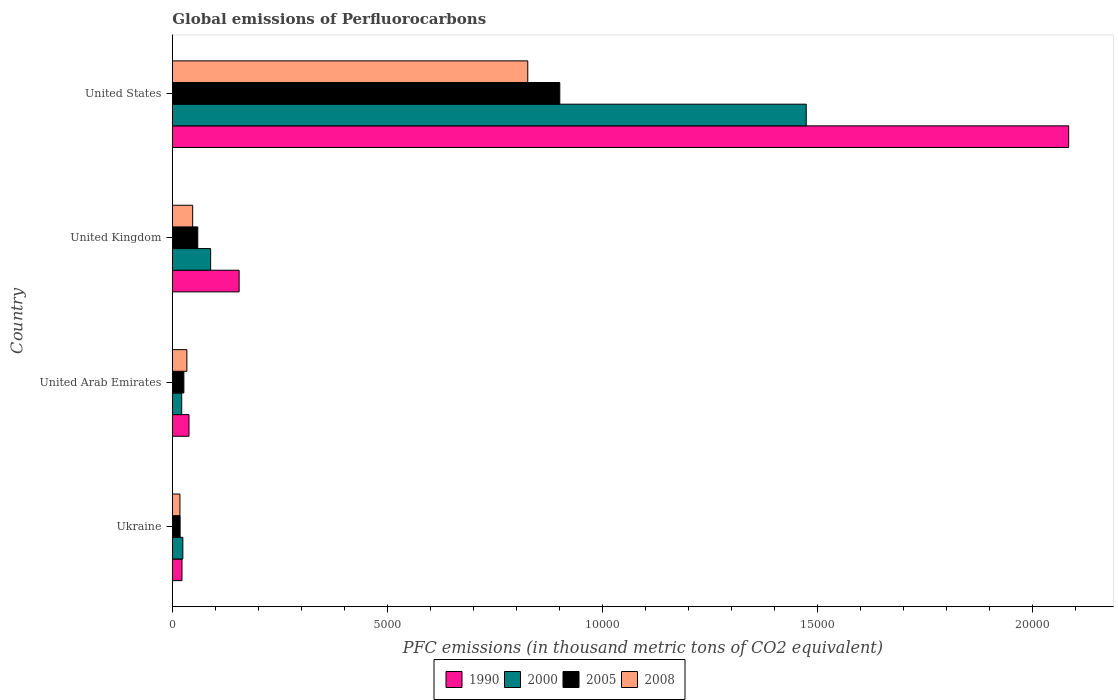Are the number of bars on each tick of the Y-axis equal?
Ensure brevity in your answer.  Yes. How many bars are there on the 2nd tick from the top?
Offer a very short reply. 4. What is the label of the 1st group of bars from the top?
Offer a terse response. United States. What is the global emissions of Perfluorocarbons in 1990 in Ukraine?
Ensure brevity in your answer.  224. Across all countries, what is the maximum global emissions of Perfluorocarbons in 1990?
Offer a terse response. 2.08e+04. Across all countries, what is the minimum global emissions of Perfluorocarbons in 2005?
Your answer should be compact. 180.5. In which country was the global emissions of Perfluorocarbons in 1990 minimum?
Keep it short and to the point. Ukraine. What is the total global emissions of Perfluorocarbons in 2008 in the graph?
Your answer should be very brief. 9250.5. What is the difference between the global emissions of Perfluorocarbons in 1990 in United Arab Emirates and that in United Kingdom?
Your answer should be very brief. -1165.2. What is the difference between the global emissions of Perfluorocarbons in 1990 in United States and the global emissions of Perfluorocarbons in 2005 in United Arab Emirates?
Give a very brief answer. 2.06e+04. What is the average global emissions of Perfluorocarbons in 2000 per country?
Provide a succinct answer. 4022.8. What is the difference between the global emissions of Perfluorocarbons in 2005 and global emissions of Perfluorocarbons in 2000 in United Kingdom?
Keep it short and to the point. -298.7. What is the ratio of the global emissions of Perfluorocarbons in 1990 in United Arab Emirates to that in United States?
Make the answer very short. 0.02. Is the difference between the global emissions of Perfluorocarbons in 2005 in Ukraine and United Arab Emirates greater than the difference between the global emissions of Perfluorocarbons in 2000 in Ukraine and United Arab Emirates?
Ensure brevity in your answer.  No. What is the difference between the highest and the second highest global emissions of Perfluorocarbons in 1990?
Offer a very short reply. 1.93e+04. What is the difference between the highest and the lowest global emissions of Perfluorocarbons in 1990?
Offer a terse response. 2.06e+04. In how many countries, is the global emissions of Perfluorocarbons in 2000 greater than the average global emissions of Perfluorocarbons in 2000 taken over all countries?
Your answer should be compact. 1. Is it the case that in every country, the sum of the global emissions of Perfluorocarbons in 2000 and global emissions of Perfluorocarbons in 1990 is greater than the sum of global emissions of Perfluorocarbons in 2005 and global emissions of Perfluorocarbons in 2008?
Your answer should be very brief. Yes. What does the 4th bar from the top in United Kingdom represents?
Your answer should be very brief. 1990. Is it the case that in every country, the sum of the global emissions of Perfluorocarbons in 2008 and global emissions of Perfluorocarbons in 2005 is greater than the global emissions of Perfluorocarbons in 2000?
Provide a short and direct response. Yes. Are all the bars in the graph horizontal?
Provide a short and direct response. Yes. Does the graph contain grids?
Provide a succinct answer. No. Where does the legend appear in the graph?
Ensure brevity in your answer.  Bottom center. How many legend labels are there?
Offer a very short reply. 4. What is the title of the graph?
Your answer should be compact. Global emissions of Perfluorocarbons. What is the label or title of the X-axis?
Give a very brief answer. PFC emissions (in thousand metric tons of CO2 equivalent). What is the PFC emissions (in thousand metric tons of CO2 equivalent) of 1990 in Ukraine?
Your response must be concise. 224. What is the PFC emissions (in thousand metric tons of CO2 equivalent) of 2000 in Ukraine?
Your answer should be compact. 244.1. What is the PFC emissions (in thousand metric tons of CO2 equivalent) in 2005 in Ukraine?
Keep it short and to the point. 180.5. What is the PFC emissions (in thousand metric tons of CO2 equivalent) in 2008 in Ukraine?
Keep it short and to the point. 176.5. What is the PFC emissions (in thousand metric tons of CO2 equivalent) of 1990 in United Arab Emirates?
Provide a succinct answer. 387.3. What is the PFC emissions (in thousand metric tons of CO2 equivalent) of 2000 in United Arab Emirates?
Provide a short and direct response. 218. What is the PFC emissions (in thousand metric tons of CO2 equivalent) of 2005 in United Arab Emirates?
Your response must be concise. 267.9. What is the PFC emissions (in thousand metric tons of CO2 equivalent) of 2008 in United Arab Emirates?
Provide a short and direct response. 337.6. What is the PFC emissions (in thousand metric tons of CO2 equivalent) in 1990 in United Kingdom?
Your answer should be compact. 1552.5. What is the PFC emissions (in thousand metric tons of CO2 equivalent) in 2000 in United Kingdom?
Offer a terse response. 890.1. What is the PFC emissions (in thousand metric tons of CO2 equivalent) of 2005 in United Kingdom?
Your response must be concise. 591.4. What is the PFC emissions (in thousand metric tons of CO2 equivalent) in 2008 in United Kingdom?
Provide a succinct answer. 472.4. What is the PFC emissions (in thousand metric tons of CO2 equivalent) in 1990 in United States?
Provide a succinct answer. 2.08e+04. What is the PFC emissions (in thousand metric tons of CO2 equivalent) in 2000 in United States?
Ensure brevity in your answer.  1.47e+04. What is the PFC emissions (in thousand metric tons of CO2 equivalent) of 2005 in United States?
Keep it short and to the point. 9008.7. What is the PFC emissions (in thousand metric tons of CO2 equivalent) in 2008 in United States?
Offer a very short reply. 8264. Across all countries, what is the maximum PFC emissions (in thousand metric tons of CO2 equivalent) in 1990?
Keep it short and to the point. 2.08e+04. Across all countries, what is the maximum PFC emissions (in thousand metric tons of CO2 equivalent) of 2000?
Your answer should be compact. 1.47e+04. Across all countries, what is the maximum PFC emissions (in thousand metric tons of CO2 equivalent) of 2005?
Provide a succinct answer. 9008.7. Across all countries, what is the maximum PFC emissions (in thousand metric tons of CO2 equivalent) in 2008?
Provide a short and direct response. 8264. Across all countries, what is the minimum PFC emissions (in thousand metric tons of CO2 equivalent) of 1990?
Make the answer very short. 224. Across all countries, what is the minimum PFC emissions (in thousand metric tons of CO2 equivalent) in 2000?
Ensure brevity in your answer.  218. Across all countries, what is the minimum PFC emissions (in thousand metric tons of CO2 equivalent) of 2005?
Provide a short and direct response. 180.5. Across all countries, what is the minimum PFC emissions (in thousand metric tons of CO2 equivalent) of 2008?
Your answer should be compact. 176.5. What is the total PFC emissions (in thousand metric tons of CO2 equivalent) in 1990 in the graph?
Offer a very short reply. 2.30e+04. What is the total PFC emissions (in thousand metric tons of CO2 equivalent) of 2000 in the graph?
Your response must be concise. 1.61e+04. What is the total PFC emissions (in thousand metric tons of CO2 equivalent) of 2005 in the graph?
Your answer should be compact. 1.00e+04. What is the total PFC emissions (in thousand metric tons of CO2 equivalent) in 2008 in the graph?
Your answer should be very brief. 9250.5. What is the difference between the PFC emissions (in thousand metric tons of CO2 equivalent) of 1990 in Ukraine and that in United Arab Emirates?
Make the answer very short. -163.3. What is the difference between the PFC emissions (in thousand metric tons of CO2 equivalent) in 2000 in Ukraine and that in United Arab Emirates?
Keep it short and to the point. 26.1. What is the difference between the PFC emissions (in thousand metric tons of CO2 equivalent) of 2005 in Ukraine and that in United Arab Emirates?
Ensure brevity in your answer.  -87.4. What is the difference between the PFC emissions (in thousand metric tons of CO2 equivalent) of 2008 in Ukraine and that in United Arab Emirates?
Offer a terse response. -161.1. What is the difference between the PFC emissions (in thousand metric tons of CO2 equivalent) of 1990 in Ukraine and that in United Kingdom?
Your answer should be compact. -1328.5. What is the difference between the PFC emissions (in thousand metric tons of CO2 equivalent) in 2000 in Ukraine and that in United Kingdom?
Keep it short and to the point. -646. What is the difference between the PFC emissions (in thousand metric tons of CO2 equivalent) of 2005 in Ukraine and that in United Kingdom?
Offer a very short reply. -410.9. What is the difference between the PFC emissions (in thousand metric tons of CO2 equivalent) of 2008 in Ukraine and that in United Kingdom?
Ensure brevity in your answer.  -295.9. What is the difference between the PFC emissions (in thousand metric tons of CO2 equivalent) of 1990 in Ukraine and that in United States?
Your answer should be compact. -2.06e+04. What is the difference between the PFC emissions (in thousand metric tons of CO2 equivalent) of 2000 in Ukraine and that in United States?
Your response must be concise. -1.45e+04. What is the difference between the PFC emissions (in thousand metric tons of CO2 equivalent) in 2005 in Ukraine and that in United States?
Offer a very short reply. -8828.2. What is the difference between the PFC emissions (in thousand metric tons of CO2 equivalent) of 2008 in Ukraine and that in United States?
Ensure brevity in your answer.  -8087.5. What is the difference between the PFC emissions (in thousand metric tons of CO2 equivalent) of 1990 in United Arab Emirates and that in United Kingdom?
Offer a very short reply. -1165.2. What is the difference between the PFC emissions (in thousand metric tons of CO2 equivalent) in 2000 in United Arab Emirates and that in United Kingdom?
Make the answer very short. -672.1. What is the difference between the PFC emissions (in thousand metric tons of CO2 equivalent) of 2005 in United Arab Emirates and that in United Kingdom?
Your answer should be very brief. -323.5. What is the difference between the PFC emissions (in thousand metric tons of CO2 equivalent) of 2008 in United Arab Emirates and that in United Kingdom?
Ensure brevity in your answer.  -134.8. What is the difference between the PFC emissions (in thousand metric tons of CO2 equivalent) in 1990 in United Arab Emirates and that in United States?
Make the answer very short. -2.05e+04. What is the difference between the PFC emissions (in thousand metric tons of CO2 equivalent) of 2000 in United Arab Emirates and that in United States?
Your answer should be very brief. -1.45e+04. What is the difference between the PFC emissions (in thousand metric tons of CO2 equivalent) of 2005 in United Arab Emirates and that in United States?
Your answer should be compact. -8740.8. What is the difference between the PFC emissions (in thousand metric tons of CO2 equivalent) of 2008 in United Arab Emirates and that in United States?
Provide a succinct answer. -7926.4. What is the difference between the PFC emissions (in thousand metric tons of CO2 equivalent) of 1990 in United Kingdom and that in United States?
Offer a very short reply. -1.93e+04. What is the difference between the PFC emissions (in thousand metric tons of CO2 equivalent) of 2000 in United Kingdom and that in United States?
Offer a very short reply. -1.38e+04. What is the difference between the PFC emissions (in thousand metric tons of CO2 equivalent) of 2005 in United Kingdom and that in United States?
Your response must be concise. -8417.3. What is the difference between the PFC emissions (in thousand metric tons of CO2 equivalent) of 2008 in United Kingdom and that in United States?
Give a very brief answer. -7791.6. What is the difference between the PFC emissions (in thousand metric tons of CO2 equivalent) in 1990 in Ukraine and the PFC emissions (in thousand metric tons of CO2 equivalent) in 2005 in United Arab Emirates?
Your answer should be compact. -43.9. What is the difference between the PFC emissions (in thousand metric tons of CO2 equivalent) in 1990 in Ukraine and the PFC emissions (in thousand metric tons of CO2 equivalent) in 2008 in United Arab Emirates?
Offer a very short reply. -113.6. What is the difference between the PFC emissions (in thousand metric tons of CO2 equivalent) of 2000 in Ukraine and the PFC emissions (in thousand metric tons of CO2 equivalent) of 2005 in United Arab Emirates?
Provide a succinct answer. -23.8. What is the difference between the PFC emissions (in thousand metric tons of CO2 equivalent) in 2000 in Ukraine and the PFC emissions (in thousand metric tons of CO2 equivalent) in 2008 in United Arab Emirates?
Offer a very short reply. -93.5. What is the difference between the PFC emissions (in thousand metric tons of CO2 equivalent) of 2005 in Ukraine and the PFC emissions (in thousand metric tons of CO2 equivalent) of 2008 in United Arab Emirates?
Provide a succinct answer. -157.1. What is the difference between the PFC emissions (in thousand metric tons of CO2 equivalent) of 1990 in Ukraine and the PFC emissions (in thousand metric tons of CO2 equivalent) of 2000 in United Kingdom?
Your answer should be compact. -666.1. What is the difference between the PFC emissions (in thousand metric tons of CO2 equivalent) of 1990 in Ukraine and the PFC emissions (in thousand metric tons of CO2 equivalent) of 2005 in United Kingdom?
Give a very brief answer. -367.4. What is the difference between the PFC emissions (in thousand metric tons of CO2 equivalent) in 1990 in Ukraine and the PFC emissions (in thousand metric tons of CO2 equivalent) in 2008 in United Kingdom?
Provide a succinct answer. -248.4. What is the difference between the PFC emissions (in thousand metric tons of CO2 equivalent) in 2000 in Ukraine and the PFC emissions (in thousand metric tons of CO2 equivalent) in 2005 in United Kingdom?
Keep it short and to the point. -347.3. What is the difference between the PFC emissions (in thousand metric tons of CO2 equivalent) of 2000 in Ukraine and the PFC emissions (in thousand metric tons of CO2 equivalent) of 2008 in United Kingdom?
Offer a very short reply. -228.3. What is the difference between the PFC emissions (in thousand metric tons of CO2 equivalent) in 2005 in Ukraine and the PFC emissions (in thousand metric tons of CO2 equivalent) in 2008 in United Kingdom?
Ensure brevity in your answer.  -291.9. What is the difference between the PFC emissions (in thousand metric tons of CO2 equivalent) of 1990 in Ukraine and the PFC emissions (in thousand metric tons of CO2 equivalent) of 2000 in United States?
Offer a terse response. -1.45e+04. What is the difference between the PFC emissions (in thousand metric tons of CO2 equivalent) of 1990 in Ukraine and the PFC emissions (in thousand metric tons of CO2 equivalent) of 2005 in United States?
Ensure brevity in your answer.  -8784.7. What is the difference between the PFC emissions (in thousand metric tons of CO2 equivalent) in 1990 in Ukraine and the PFC emissions (in thousand metric tons of CO2 equivalent) in 2008 in United States?
Offer a terse response. -8040. What is the difference between the PFC emissions (in thousand metric tons of CO2 equivalent) in 2000 in Ukraine and the PFC emissions (in thousand metric tons of CO2 equivalent) in 2005 in United States?
Your answer should be compact. -8764.6. What is the difference between the PFC emissions (in thousand metric tons of CO2 equivalent) of 2000 in Ukraine and the PFC emissions (in thousand metric tons of CO2 equivalent) of 2008 in United States?
Make the answer very short. -8019.9. What is the difference between the PFC emissions (in thousand metric tons of CO2 equivalent) in 2005 in Ukraine and the PFC emissions (in thousand metric tons of CO2 equivalent) in 2008 in United States?
Offer a terse response. -8083.5. What is the difference between the PFC emissions (in thousand metric tons of CO2 equivalent) in 1990 in United Arab Emirates and the PFC emissions (in thousand metric tons of CO2 equivalent) in 2000 in United Kingdom?
Ensure brevity in your answer.  -502.8. What is the difference between the PFC emissions (in thousand metric tons of CO2 equivalent) in 1990 in United Arab Emirates and the PFC emissions (in thousand metric tons of CO2 equivalent) in 2005 in United Kingdom?
Your answer should be very brief. -204.1. What is the difference between the PFC emissions (in thousand metric tons of CO2 equivalent) of 1990 in United Arab Emirates and the PFC emissions (in thousand metric tons of CO2 equivalent) of 2008 in United Kingdom?
Make the answer very short. -85.1. What is the difference between the PFC emissions (in thousand metric tons of CO2 equivalent) in 2000 in United Arab Emirates and the PFC emissions (in thousand metric tons of CO2 equivalent) in 2005 in United Kingdom?
Give a very brief answer. -373.4. What is the difference between the PFC emissions (in thousand metric tons of CO2 equivalent) of 2000 in United Arab Emirates and the PFC emissions (in thousand metric tons of CO2 equivalent) of 2008 in United Kingdom?
Ensure brevity in your answer.  -254.4. What is the difference between the PFC emissions (in thousand metric tons of CO2 equivalent) of 2005 in United Arab Emirates and the PFC emissions (in thousand metric tons of CO2 equivalent) of 2008 in United Kingdom?
Provide a short and direct response. -204.5. What is the difference between the PFC emissions (in thousand metric tons of CO2 equivalent) of 1990 in United Arab Emirates and the PFC emissions (in thousand metric tons of CO2 equivalent) of 2000 in United States?
Provide a succinct answer. -1.44e+04. What is the difference between the PFC emissions (in thousand metric tons of CO2 equivalent) of 1990 in United Arab Emirates and the PFC emissions (in thousand metric tons of CO2 equivalent) of 2005 in United States?
Keep it short and to the point. -8621.4. What is the difference between the PFC emissions (in thousand metric tons of CO2 equivalent) in 1990 in United Arab Emirates and the PFC emissions (in thousand metric tons of CO2 equivalent) in 2008 in United States?
Offer a terse response. -7876.7. What is the difference between the PFC emissions (in thousand metric tons of CO2 equivalent) of 2000 in United Arab Emirates and the PFC emissions (in thousand metric tons of CO2 equivalent) of 2005 in United States?
Offer a very short reply. -8790.7. What is the difference between the PFC emissions (in thousand metric tons of CO2 equivalent) in 2000 in United Arab Emirates and the PFC emissions (in thousand metric tons of CO2 equivalent) in 2008 in United States?
Ensure brevity in your answer.  -8046. What is the difference between the PFC emissions (in thousand metric tons of CO2 equivalent) of 2005 in United Arab Emirates and the PFC emissions (in thousand metric tons of CO2 equivalent) of 2008 in United States?
Give a very brief answer. -7996.1. What is the difference between the PFC emissions (in thousand metric tons of CO2 equivalent) of 1990 in United Kingdom and the PFC emissions (in thousand metric tons of CO2 equivalent) of 2000 in United States?
Offer a very short reply. -1.32e+04. What is the difference between the PFC emissions (in thousand metric tons of CO2 equivalent) in 1990 in United Kingdom and the PFC emissions (in thousand metric tons of CO2 equivalent) in 2005 in United States?
Your response must be concise. -7456.2. What is the difference between the PFC emissions (in thousand metric tons of CO2 equivalent) of 1990 in United Kingdom and the PFC emissions (in thousand metric tons of CO2 equivalent) of 2008 in United States?
Give a very brief answer. -6711.5. What is the difference between the PFC emissions (in thousand metric tons of CO2 equivalent) in 2000 in United Kingdom and the PFC emissions (in thousand metric tons of CO2 equivalent) in 2005 in United States?
Provide a short and direct response. -8118.6. What is the difference between the PFC emissions (in thousand metric tons of CO2 equivalent) of 2000 in United Kingdom and the PFC emissions (in thousand metric tons of CO2 equivalent) of 2008 in United States?
Give a very brief answer. -7373.9. What is the difference between the PFC emissions (in thousand metric tons of CO2 equivalent) of 2005 in United Kingdom and the PFC emissions (in thousand metric tons of CO2 equivalent) of 2008 in United States?
Give a very brief answer. -7672.6. What is the average PFC emissions (in thousand metric tons of CO2 equivalent) in 1990 per country?
Give a very brief answer. 5751.27. What is the average PFC emissions (in thousand metric tons of CO2 equivalent) in 2000 per country?
Make the answer very short. 4022.8. What is the average PFC emissions (in thousand metric tons of CO2 equivalent) of 2005 per country?
Offer a very short reply. 2512.12. What is the average PFC emissions (in thousand metric tons of CO2 equivalent) of 2008 per country?
Your answer should be very brief. 2312.62. What is the difference between the PFC emissions (in thousand metric tons of CO2 equivalent) of 1990 and PFC emissions (in thousand metric tons of CO2 equivalent) of 2000 in Ukraine?
Your response must be concise. -20.1. What is the difference between the PFC emissions (in thousand metric tons of CO2 equivalent) of 1990 and PFC emissions (in thousand metric tons of CO2 equivalent) of 2005 in Ukraine?
Your answer should be very brief. 43.5. What is the difference between the PFC emissions (in thousand metric tons of CO2 equivalent) in 1990 and PFC emissions (in thousand metric tons of CO2 equivalent) in 2008 in Ukraine?
Offer a very short reply. 47.5. What is the difference between the PFC emissions (in thousand metric tons of CO2 equivalent) of 2000 and PFC emissions (in thousand metric tons of CO2 equivalent) of 2005 in Ukraine?
Give a very brief answer. 63.6. What is the difference between the PFC emissions (in thousand metric tons of CO2 equivalent) of 2000 and PFC emissions (in thousand metric tons of CO2 equivalent) of 2008 in Ukraine?
Keep it short and to the point. 67.6. What is the difference between the PFC emissions (in thousand metric tons of CO2 equivalent) of 2005 and PFC emissions (in thousand metric tons of CO2 equivalent) of 2008 in Ukraine?
Your answer should be compact. 4. What is the difference between the PFC emissions (in thousand metric tons of CO2 equivalent) in 1990 and PFC emissions (in thousand metric tons of CO2 equivalent) in 2000 in United Arab Emirates?
Give a very brief answer. 169.3. What is the difference between the PFC emissions (in thousand metric tons of CO2 equivalent) of 1990 and PFC emissions (in thousand metric tons of CO2 equivalent) of 2005 in United Arab Emirates?
Make the answer very short. 119.4. What is the difference between the PFC emissions (in thousand metric tons of CO2 equivalent) of 1990 and PFC emissions (in thousand metric tons of CO2 equivalent) of 2008 in United Arab Emirates?
Keep it short and to the point. 49.7. What is the difference between the PFC emissions (in thousand metric tons of CO2 equivalent) in 2000 and PFC emissions (in thousand metric tons of CO2 equivalent) in 2005 in United Arab Emirates?
Your response must be concise. -49.9. What is the difference between the PFC emissions (in thousand metric tons of CO2 equivalent) of 2000 and PFC emissions (in thousand metric tons of CO2 equivalent) of 2008 in United Arab Emirates?
Make the answer very short. -119.6. What is the difference between the PFC emissions (in thousand metric tons of CO2 equivalent) in 2005 and PFC emissions (in thousand metric tons of CO2 equivalent) in 2008 in United Arab Emirates?
Give a very brief answer. -69.7. What is the difference between the PFC emissions (in thousand metric tons of CO2 equivalent) in 1990 and PFC emissions (in thousand metric tons of CO2 equivalent) in 2000 in United Kingdom?
Ensure brevity in your answer.  662.4. What is the difference between the PFC emissions (in thousand metric tons of CO2 equivalent) in 1990 and PFC emissions (in thousand metric tons of CO2 equivalent) in 2005 in United Kingdom?
Your answer should be very brief. 961.1. What is the difference between the PFC emissions (in thousand metric tons of CO2 equivalent) of 1990 and PFC emissions (in thousand metric tons of CO2 equivalent) of 2008 in United Kingdom?
Your answer should be compact. 1080.1. What is the difference between the PFC emissions (in thousand metric tons of CO2 equivalent) of 2000 and PFC emissions (in thousand metric tons of CO2 equivalent) of 2005 in United Kingdom?
Keep it short and to the point. 298.7. What is the difference between the PFC emissions (in thousand metric tons of CO2 equivalent) of 2000 and PFC emissions (in thousand metric tons of CO2 equivalent) of 2008 in United Kingdom?
Provide a short and direct response. 417.7. What is the difference between the PFC emissions (in thousand metric tons of CO2 equivalent) of 2005 and PFC emissions (in thousand metric tons of CO2 equivalent) of 2008 in United Kingdom?
Your response must be concise. 119. What is the difference between the PFC emissions (in thousand metric tons of CO2 equivalent) in 1990 and PFC emissions (in thousand metric tons of CO2 equivalent) in 2000 in United States?
Make the answer very short. 6102.3. What is the difference between the PFC emissions (in thousand metric tons of CO2 equivalent) in 1990 and PFC emissions (in thousand metric tons of CO2 equivalent) in 2005 in United States?
Provide a succinct answer. 1.18e+04. What is the difference between the PFC emissions (in thousand metric tons of CO2 equivalent) in 1990 and PFC emissions (in thousand metric tons of CO2 equivalent) in 2008 in United States?
Offer a very short reply. 1.26e+04. What is the difference between the PFC emissions (in thousand metric tons of CO2 equivalent) of 2000 and PFC emissions (in thousand metric tons of CO2 equivalent) of 2005 in United States?
Give a very brief answer. 5730.3. What is the difference between the PFC emissions (in thousand metric tons of CO2 equivalent) of 2000 and PFC emissions (in thousand metric tons of CO2 equivalent) of 2008 in United States?
Your answer should be compact. 6475. What is the difference between the PFC emissions (in thousand metric tons of CO2 equivalent) of 2005 and PFC emissions (in thousand metric tons of CO2 equivalent) of 2008 in United States?
Your response must be concise. 744.7. What is the ratio of the PFC emissions (in thousand metric tons of CO2 equivalent) in 1990 in Ukraine to that in United Arab Emirates?
Provide a short and direct response. 0.58. What is the ratio of the PFC emissions (in thousand metric tons of CO2 equivalent) in 2000 in Ukraine to that in United Arab Emirates?
Make the answer very short. 1.12. What is the ratio of the PFC emissions (in thousand metric tons of CO2 equivalent) in 2005 in Ukraine to that in United Arab Emirates?
Your answer should be compact. 0.67. What is the ratio of the PFC emissions (in thousand metric tons of CO2 equivalent) of 2008 in Ukraine to that in United Arab Emirates?
Ensure brevity in your answer.  0.52. What is the ratio of the PFC emissions (in thousand metric tons of CO2 equivalent) of 1990 in Ukraine to that in United Kingdom?
Provide a succinct answer. 0.14. What is the ratio of the PFC emissions (in thousand metric tons of CO2 equivalent) in 2000 in Ukraine to that in United Kingdom?
Give a very brief answer. 0.27. What is the ratio of the PFC emissions (in thousand metric tons of CO2 equivalent) of 2005 in Ukraine to that in United Kingdom?
Offer a terse response. 0.31. What is the ratio of the PFC emissions (in thousand metric tons of CO2 equivalent) in 2008 in Ukraine to that in United Kingdom?
Your answer should be very brief. 0.37. What is the ratio of the PFC emissions (in thousand metric tons of CO2 equivalent) of 1990 in Ukraine to that in United States?
Your answer should be very brief. 0.01. What is the ratio of the PFC emissions (in thousand metric tons of CO2 equivalent) in 2000 in Ukraine to that in United States?
Your answer should be very brief. 0.02. What is the ratio of the PFC emissions (in thousand metric tons of CO2 equivalent) in 2005 in Ukraine to that in United States?
Your answer should be very brief. 0.02. What is the ratio of the PFC emissions (in thousand metric tons of CO2 equivalent) of 2008 in Ukraine to that in United States?
Ensure brevity in your answer.  0.02. What is the ratio of the PFC emissions (in thousand metric tons of CO2 equivalent) of 1990 in United Arab Emirates to that in United Kingdom?
Keep it short and to the point. 0.25. What is the ratio of the PFC emissions (in thousand metric tons of CO2 equivalent) in 2000 in United Arab Emirates to that in United Kingdom?
Give a very brief answer. 0.24. What is the ratio of the PFC emissions (in thousand metric tons of CO2 equivalent) in 2005 in United Arab Emirates to that in United Kingdom?
Offer a terse response. 0.45. What is the ratio of the PFC emissions (in thousand metric tons of CO2 equivalent) in 2008 in United Arab Emirates to that in United Kingdom?
Offer a very short reply. 0.71. What is the ratio of the PFC emissions (in thousand metric tons of CO2 equivalent) in 1990 in United Arab Emirates to that in United States?
Your response must be concise. 0.02. What is the ratio of the PFC emissions (in thousand metric tons of CO2 equivalent) in 2000 in United Arab Emirates to that in United States?
Offer a terse response. 0.01. What is the ratio of the PFC emissions (in thousand metric tons of CO2 equivalent) in 2005 in United Arab Emirates to that in United States?
Your response must be concise. 0.03. What is the ratio of the PFC emissions (in thousand metric tons of CO2 equivalent) of 2008 in United Arab Emirates to that in United States?
Provide a short and direct response. 0.04. What is the ratio of the PFC emissions (in thousand metric tons of CO2 equivalent) of 1990 in United Kingdom to that in United States?
Offer a terse response. 0.07. What is the ratio of the PFC emissions (in thousand metric tons of CO2 equivalent) of 2000 in United Kingdom to that in United States?
Give a very brief answer. 0.06. What is the ratio of the PFC emissions (in thousand metric tons of CO2 equivalent) of 2005 in United Kingdom to that in United States?
Make the answer very short. 0.07. What is the ratio of the PFC emissions (in thousand metric tons of CO2 equivalent) of 2008 in United Kingdom to that in United States?
Keep it short and to the point. 0.06. What is the difference between the highest and the second highest PFC emissions (in thousand metric tons of CO2 equivalent) in 1990?
Ensure brevity in your answer.  1.93e+04. What is the difference between the highest and the second highest PFC emissions (in thousand metric tons of CO2 equivalent) of 2000?
Offer a very short reply. 1.38e+04. What is the difference between the highest and the second highest PFC emissions (in thousand metric tons of CO2 equivalent) of 2005?
Give a very brief answer. 8417.3. What is the difference between the highest and the second highest PFC emissions (in thousand metric tons of CO2 equivalent) of 2008?
Offer a terse response. 7791.6. What is the difference between the highest and the lowest PFC emissions (in thousand metric tons of CO2 equivalent) of 1990?
Your response must be concise. 2.06e+04. What is the difference between the highest and the lowest PFC emissions (in thousand metric tons of CO2 equivalent) of 2000?
Your answer should be very brief. 1.45e+04. What is the difference between the highest and the lowest PFC emissions (in thousand metric tons of CO2 equivalent) in 2005?
Offer a terse response. 8828.2. What is the difference between the highest and the lowest PFC emissions (in thousand metric tons of CO2 equivalent) of 2008?
Provide a short and direct response. 8087.5. 